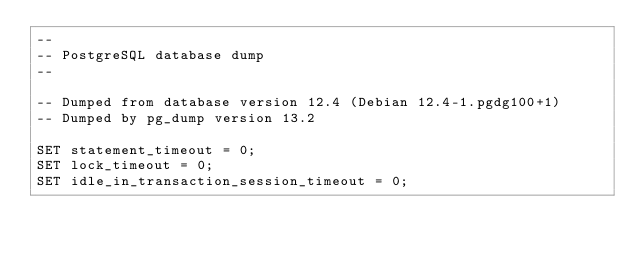<code> <loc_0><loc_0><loc_500><loc_500><_SQL_>--
-- PostgreSQL database dump
--

-- Dumped from database version 12.4 (Debian 12.4-1.pgdg100+1)
-- Dumped by pg_dump version 13.2

SET statement_timeout = 0;
SET lock_timeout = 0;
SET idle_in_transaction_session_timeout = 0;</code> 